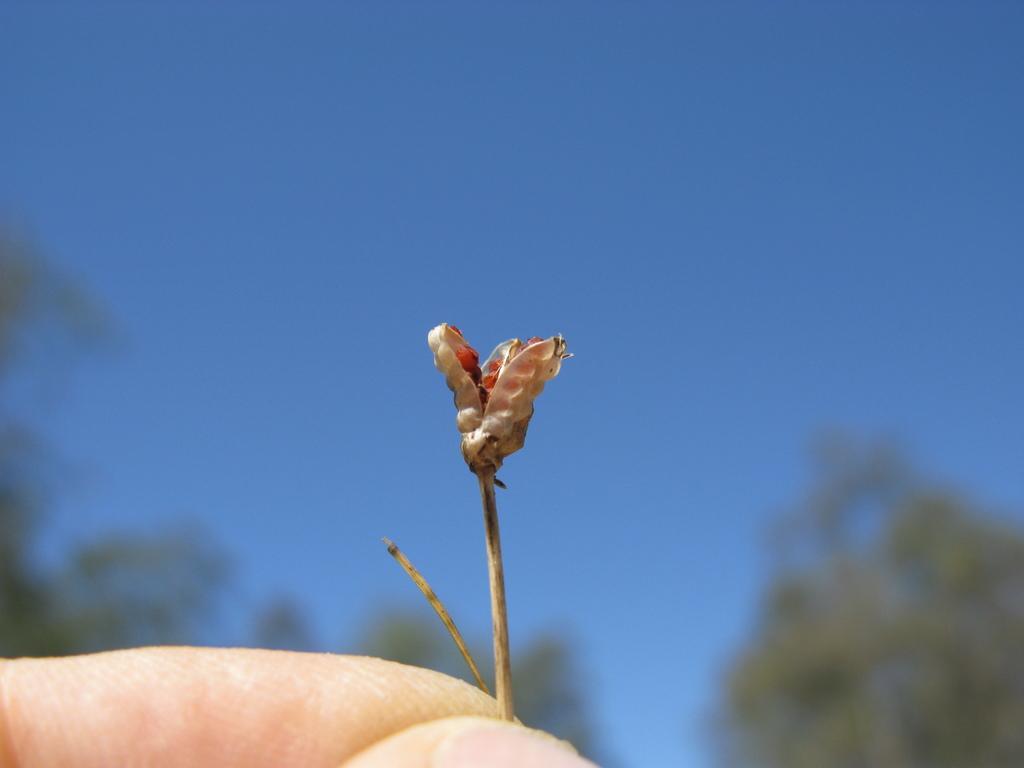How would you summarize this image in a sentence or two? This is the picture of a flower which is in the person hand and behind there are some trees. 